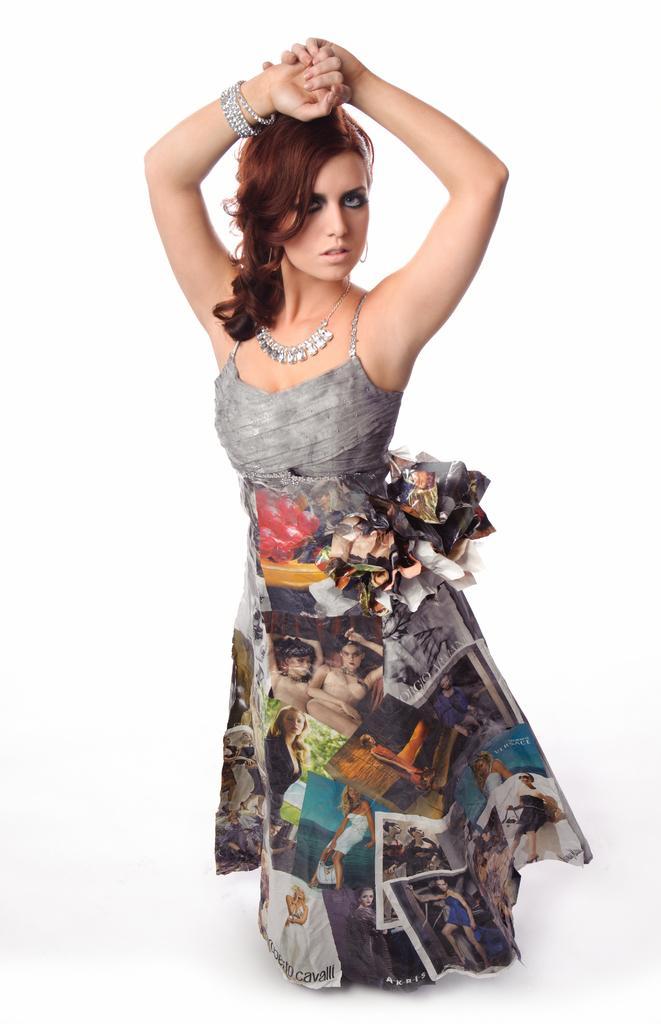In one or two sentences, can you explain what this image depicts? In this image there is a woman standing. 